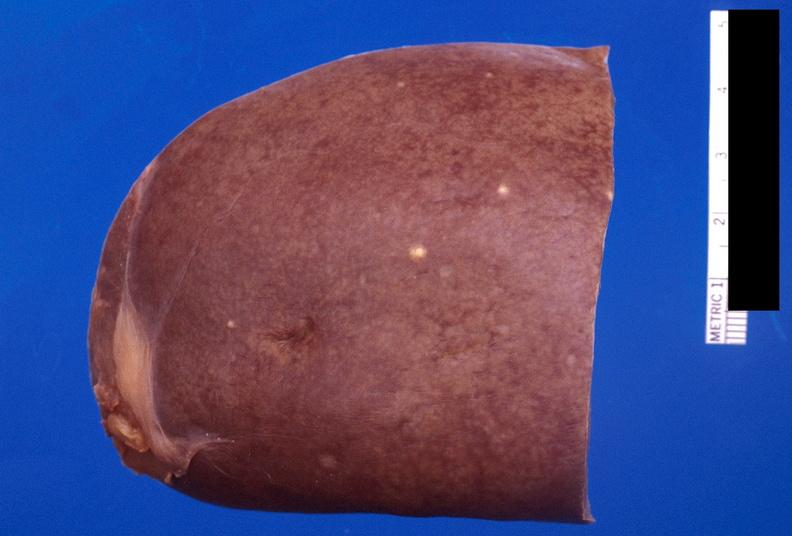what does this image show?
Answer the question using a single word or phrase. Spleen 